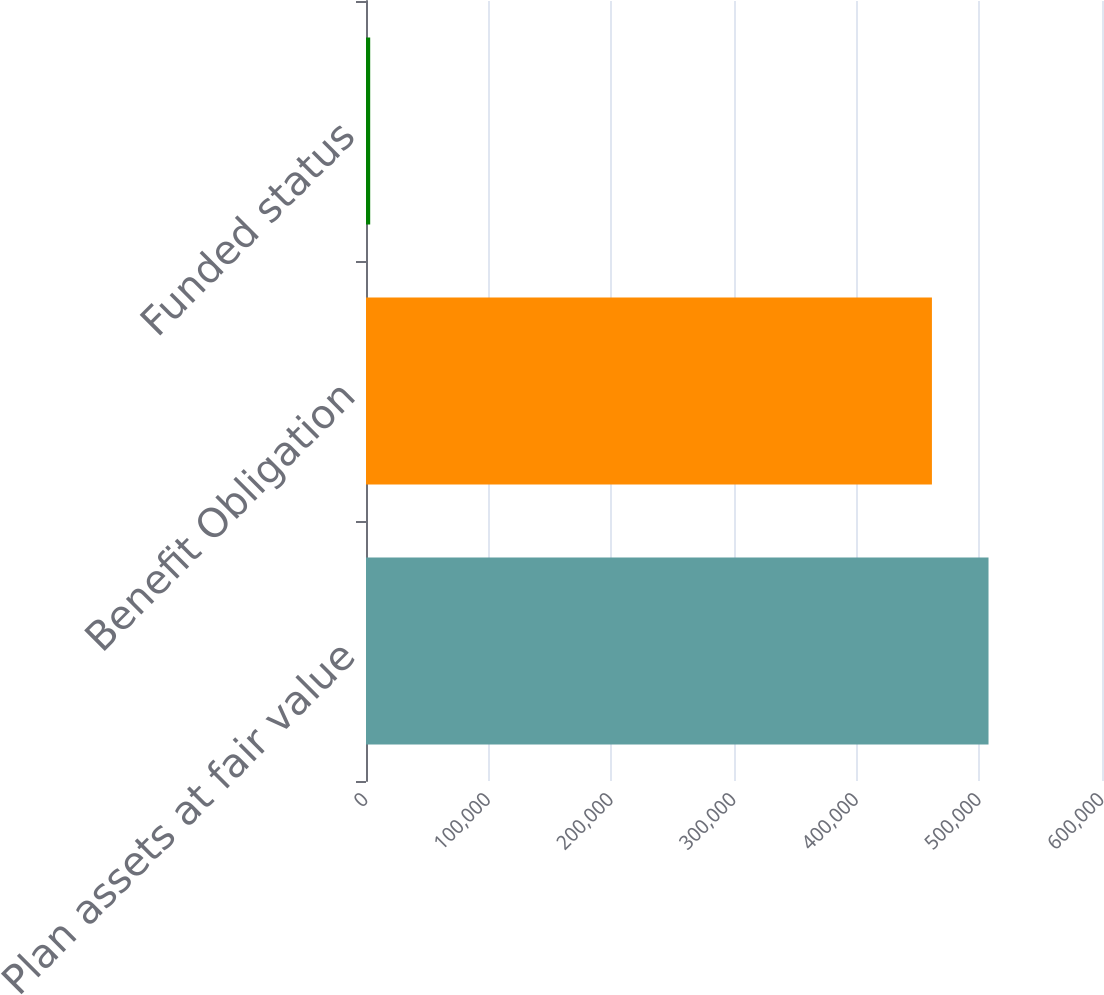Convert chart to OTSL. <chart><loc_0><loc_0><loc_500><loc_500><bar_chart><fcel>Plan assets at fair value<fcel>Benefit Obligation<fcel>Funded status<nl><fcel>507490<fcel>461355<fcel>3424<nl></chart> 